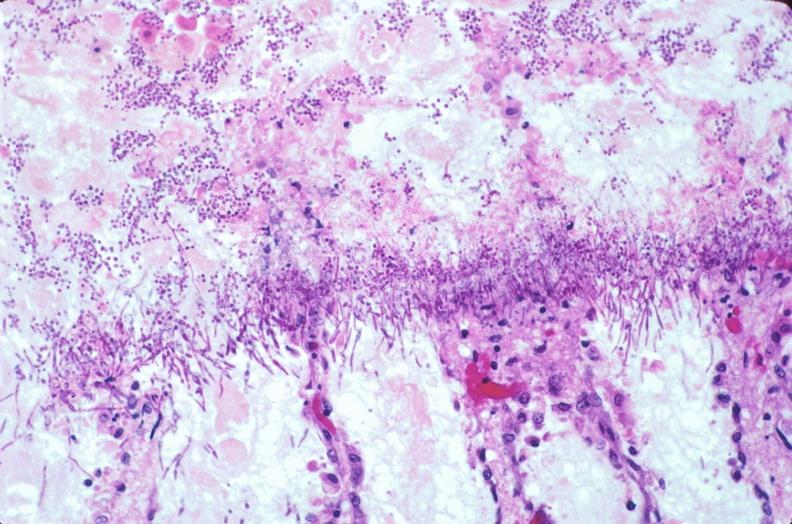s gastrointestinal present?
Answer the question using a single word or phrase. Yes 